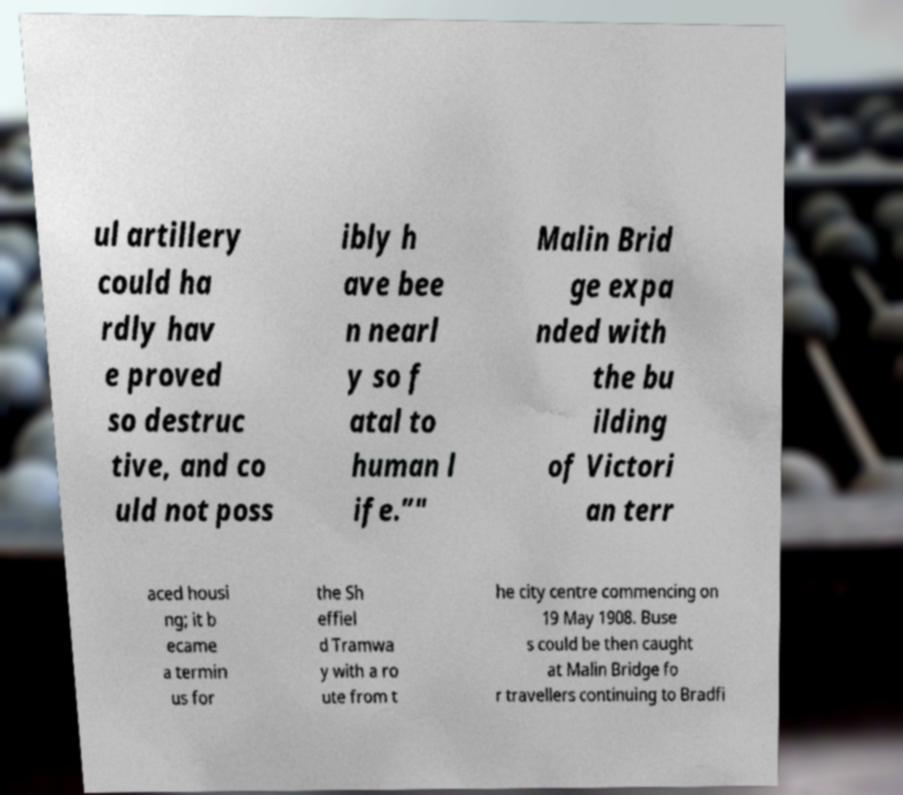Can you accurately transcribe the text from the provided image for me? ul artillery could ha rdly hav e proved so destruc tive, and co uld not poss ibly h ave bee n nearl y so f atal to human l ife.”" Malin Brid ge expa nded with the bu ilding of Victori an terr aced housi ng; it b ecame a termin us for the Sh effiel d Tramwa y with a ro ute from t he city centre commencing on 19 May 1908. Buse s could be then caught at Malin Bridge fo r travellers continuing to Bradfi 